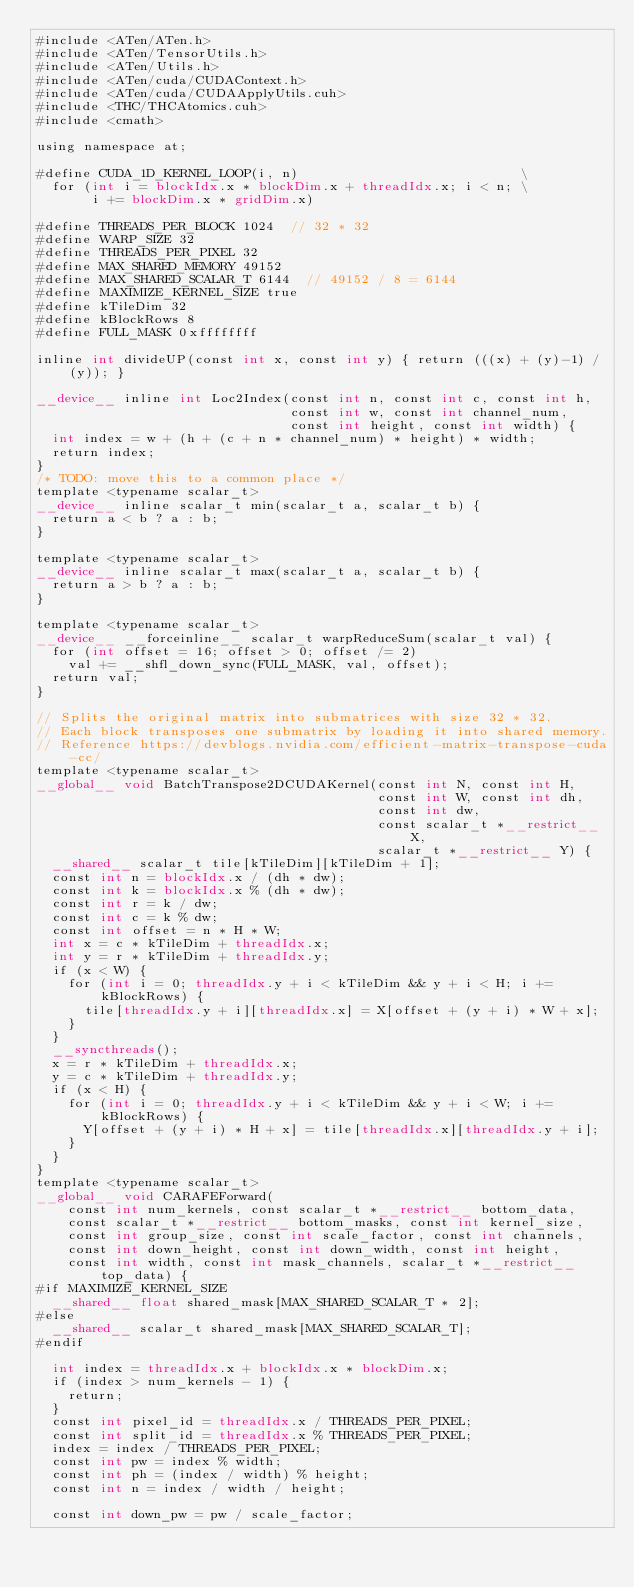Convert code to text. <code><loc_0><loc_0><loc_500><loc_500><_Cuda_>#include <ATen/ATen.h>
#include <ATen/TensorUtils.h>
#include <ATen/Utils.h>
#include <ATen/cuda/CUDAContext.h>
#include <ATen/cuda/CUDAApplyUtils.cuh>
#include <THC/THCAtomics.cuh>
#include <cmath>

using namespace at;

#define CUDA_1D_KERNEL_LOOP(i, n)                            \
  for (int i = blockIdx.x * blockDim.x + threadIdx.x; i < n; \
       i += blockDim.x * gridDim.x)

#define THREADS_PER_BLOCK 1024  // 32 * 32
#define WARP_SIZE 32
#define THREADS_PER_PIXEL 32
#define MAX_SHARED_MEMORY 49152
#define MAX_SHARED_SCALAR_T 6144  // 49152 / 8 = 6144
#define MAXIMIZE_KERNEL_SIZE true
#define kTileDim 32
#define kBlockRows 8
#define FULL_MASK 0xffffffff

inline int divideUP(const int x, const int y) { return (((x) + (y)-1) / (y)); }

__device__ inline int Loc2Index(const int n, const int c, const int h,
                                const int w, const int channel_num,
                                const int height, const int width) {
  int index = w + (h + (c + n * channel_num) * height) * width;
  return index;
}
/* TODO: move this to a common place */
template <typename scalar_t>
__device__ inline scalar_t min(scalar_t a, scalar_t b) {
  return a < b ? a : b;
}

template <typename scalar_t>
__device__ inline scalar_t max(scalar_t a, scalar_t b) {
  return a > b ? a : b;
}

template <typename scalar_t>
__device__ __forceinline__ scalar_t warpReduceSum(scalar_t val) {
  for (int offset = 16; offset > 0; offset /= 2)
    val += __shfl_down_sync(FULL_MASK, val, offset);
  return val;
}

// Splits the original matrix into submatrices with size 32 * 32.
// Each block transposes one submatrix by loading it into shared memory.
// Reference https://devblogs.nvidia.com/efficient-matrix-transpose-cuda-cc/
template <typename scalar_t>
__global__ void BatchTranspose2DCUDAKernel(const int N, const int H,
                                           const int W, const int dh,
                                           const int dw,
                                           const scalar_t *__restrict__ X,
                                           scalar_t *__restrict__ Y) {
  __shared__ scalar_t tile[kTileDim][kTileDim + 1];
  const int n = blockIdx.x / (dh * dw);
  const int k = blockIdx.x % (dh * dw);
  const int r = k / dw;
  const int c = k % dw;
  const int offset = n * H * W;
  int x = c * kTileDim + threadIdx.x;
  int y = r * kTileDim + threadIdx.y;
  if (x < W) {
    for (int i = 0; threadIdx.y + i < kTileDim && y + i < H; i += kBlockRows) {
      tile[threadIdx.y + i][threadIdx.x] = X[offset + (y + i) * W + x];
    }
  }
  __syncthreads();
  x = r * kTileDim + threadIdx.x;
  y = c * kTileDim + threadIdx.y;
  if (x < H) {
    for (int i = 0; threadIdx.y + i < kTileDim && y + i < W; i += kBlockRows) {
      Y[offset + (y + i) * H + x] = tile[threadIdx.x][threadIdx.y + i];
    }
  }
}
template <typename scalar_t>
__global__ void CARAFEForward(
    const int num_kernels, const scalar_t *__restrict__ bottom_data,
    const scalar_t *__restrict__ bottom_masks, const int kernel_size,
    const int group_size, const int scale_factor, const int channels,
    const int down_height, const int down_width, const int height,
    const int width, const int mask_channels, scalar_t *__restrict__ top_data) {
#if MAXIMIZE_KERNEL_SIZE
  __shared__ float shared_mask[MAX_SHARED_SCALAR_T * 2];
#else
  __shared__ scalar_t shared_mask[MAX_SHARED_SCALAR_T];
#endif

  int index = threadIdx.x + blockIdx.x * blockDim.x;
  if (index > num_kernels - 1) {
    return;
  }
  const int pixel_id = threadIdx.x / THREADS_PER_PIXEL;
  const int split_id = threadIdx.x % THREADS_PER_PIXEL;
  index = index / THREADS_PER_PIXEL;
  const int pw = index % width;
  const int ph = (index / width) % height;
  const int n = index / width / height;

  const int down_pw = pw / scale_factor;</code> 